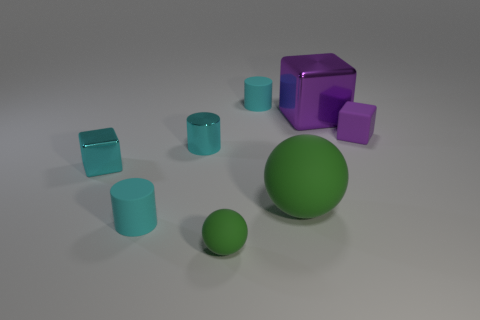What number of metal objects are large green objects or big purple cubes?
Your answer should be compact. 1. What number of yellow things are tiny shiny things or large rubber objects?
Your answer should be very brief. 0. There is a metal thing to the right of the cyan metal cylinder; is its color the same as the small metallic cylinder?
Your answer should be very brief. No. Is the tiny green object made of the same material as the big cube?
Your response must be concise. No. Is the number of matte balls behind the large metal object the same as the number of metal blocks that are in front of the tiny purple thing?
Provide a succinct answer. No. What material is the big object that is the same shape as the small purple thing?
Your answer should be very brief. Metal. The purple thing in front of the purple block that is behind the small purple object behind the small green sphere is what shape?
Provide a succinct answer. Cube. Are there more cyan objects that are in front of the large green sphere than shiny blocks?
Give a very brief answer. No. There is a cyan rubber object in front of the big ball; does it have the same shape as the big green rubber thing?
Your response must be concise. No. What is the material of the small cube that is on the right side of the big metal cube?
Give a very brief answer. Rubber. 